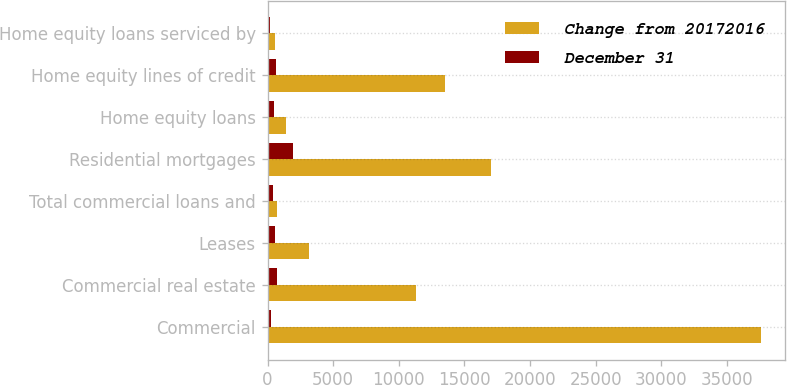<chart> <loc_0><loc_0><loc_500><loc_500><stacked_bar_chart><ecel><fcel>Commercial<fcel>Commercial real estate<fcel>Leases<fcel>Total commercial loans and<fcel>Residential mortgages<fcel>Home equity loans<fcel>Home equity lines of credit<fcel>Home equity loans serviced by<nl><fcel>Change from 20172016<fcel>37562<fcel>11308<fcel>3161<fcel>684<fcel>17045<fcel>1392<fcel>13483<fcel>542<nl><fcel>December 31<fcel>288<fcel>684<fcel>592<fcel>380<fcel>1930<fcel>466<fcel>617<fcel>208<nl></chart> 